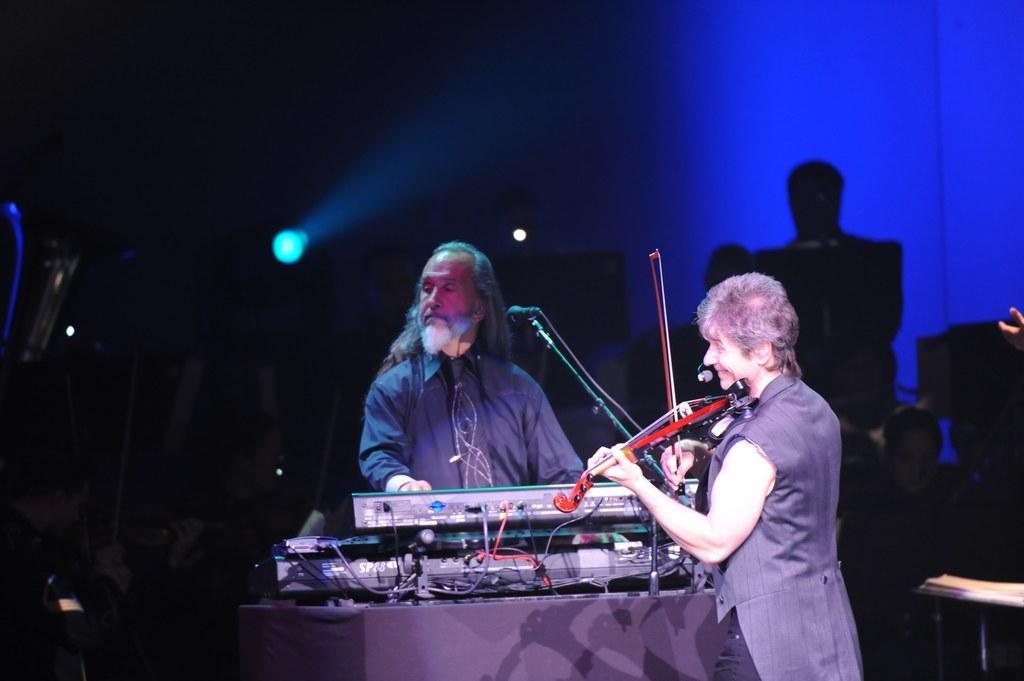In one or two sentences, can you explain what this image depicts? In this image in front there are two people playing musical instruments. Behind them there are a few other people. In the background of the image there are lights. 